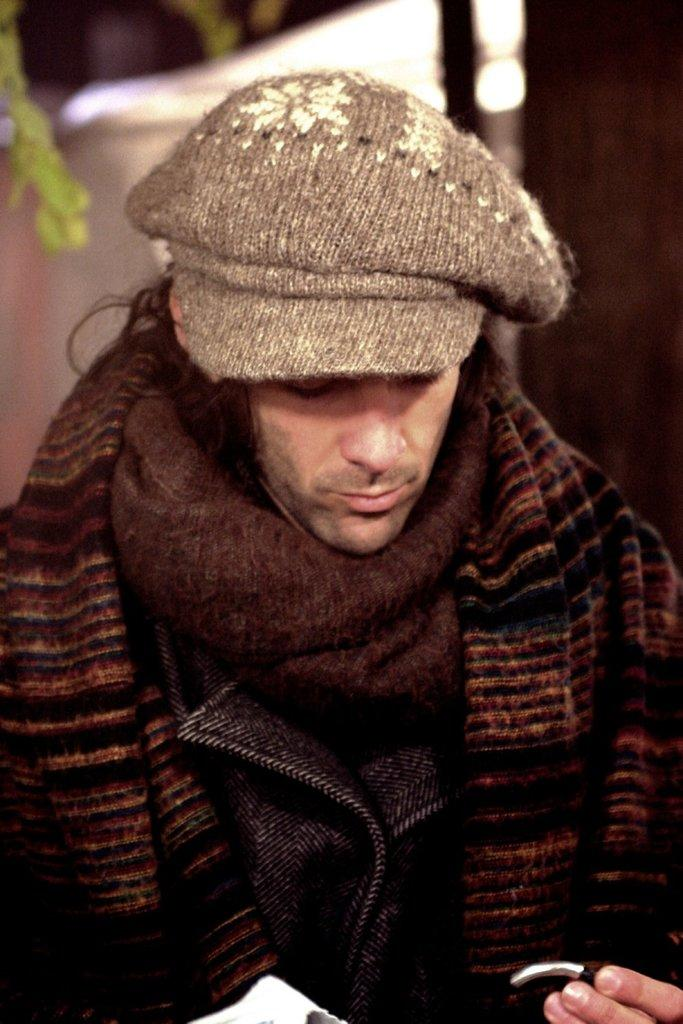What is the main subject of the image? There is a man in the image. How many balls are being cracked against the brick wall in the image? There are no balls or brick walls present in the image; it features a man as the main subject. 